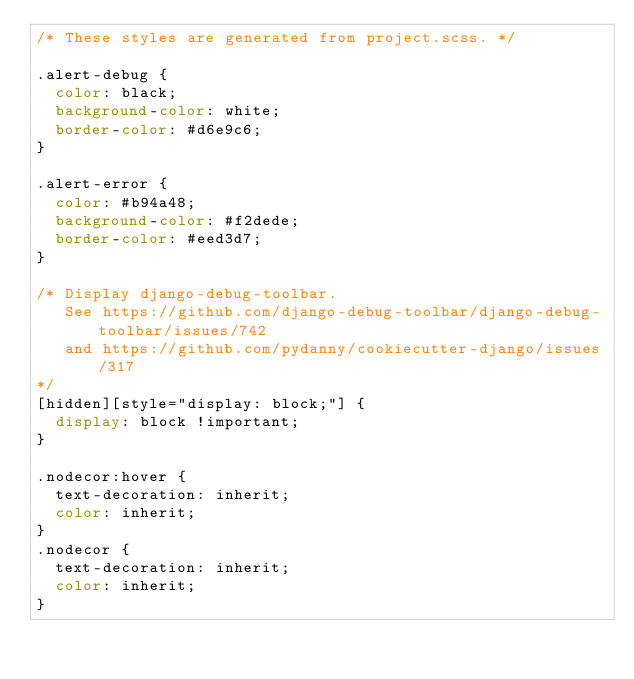<code> <loc_0><loc_0><loc_500><loc_500><_CSS_>/* These styles are generated from project.scss. */

.alert-debug {
  color: black;
  background-color: white;
  border-color: #d6e9c6;
}

.alert-error {
  color: #b94a48;
  background-color: #f2dede;
  border-color: #eed3d7;
}

/* Display django-debug-toolbar.
   See https://github.com/django-debug-toolbar/django-debug-toolbar/issues/742
   and https://github.com/pydanny/cookiecutter-django/issues/317
*/
[hidden][style="display: block;"] {
  display: block !important;
}

.nodecor:hover {
  text-decoration: inherit;
  color: inherit;
}
.nodecor {
  text-decoration: inherit;
  color: inherit;
}
</code> 